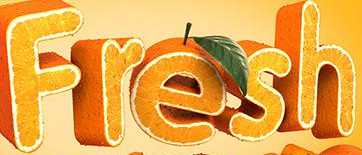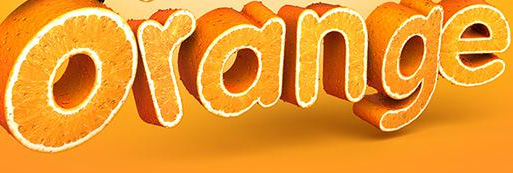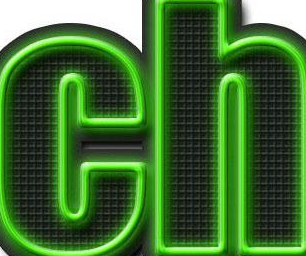What words can you see in these images in sequence, separated by a semicolon? Fresh; Orange; ch 